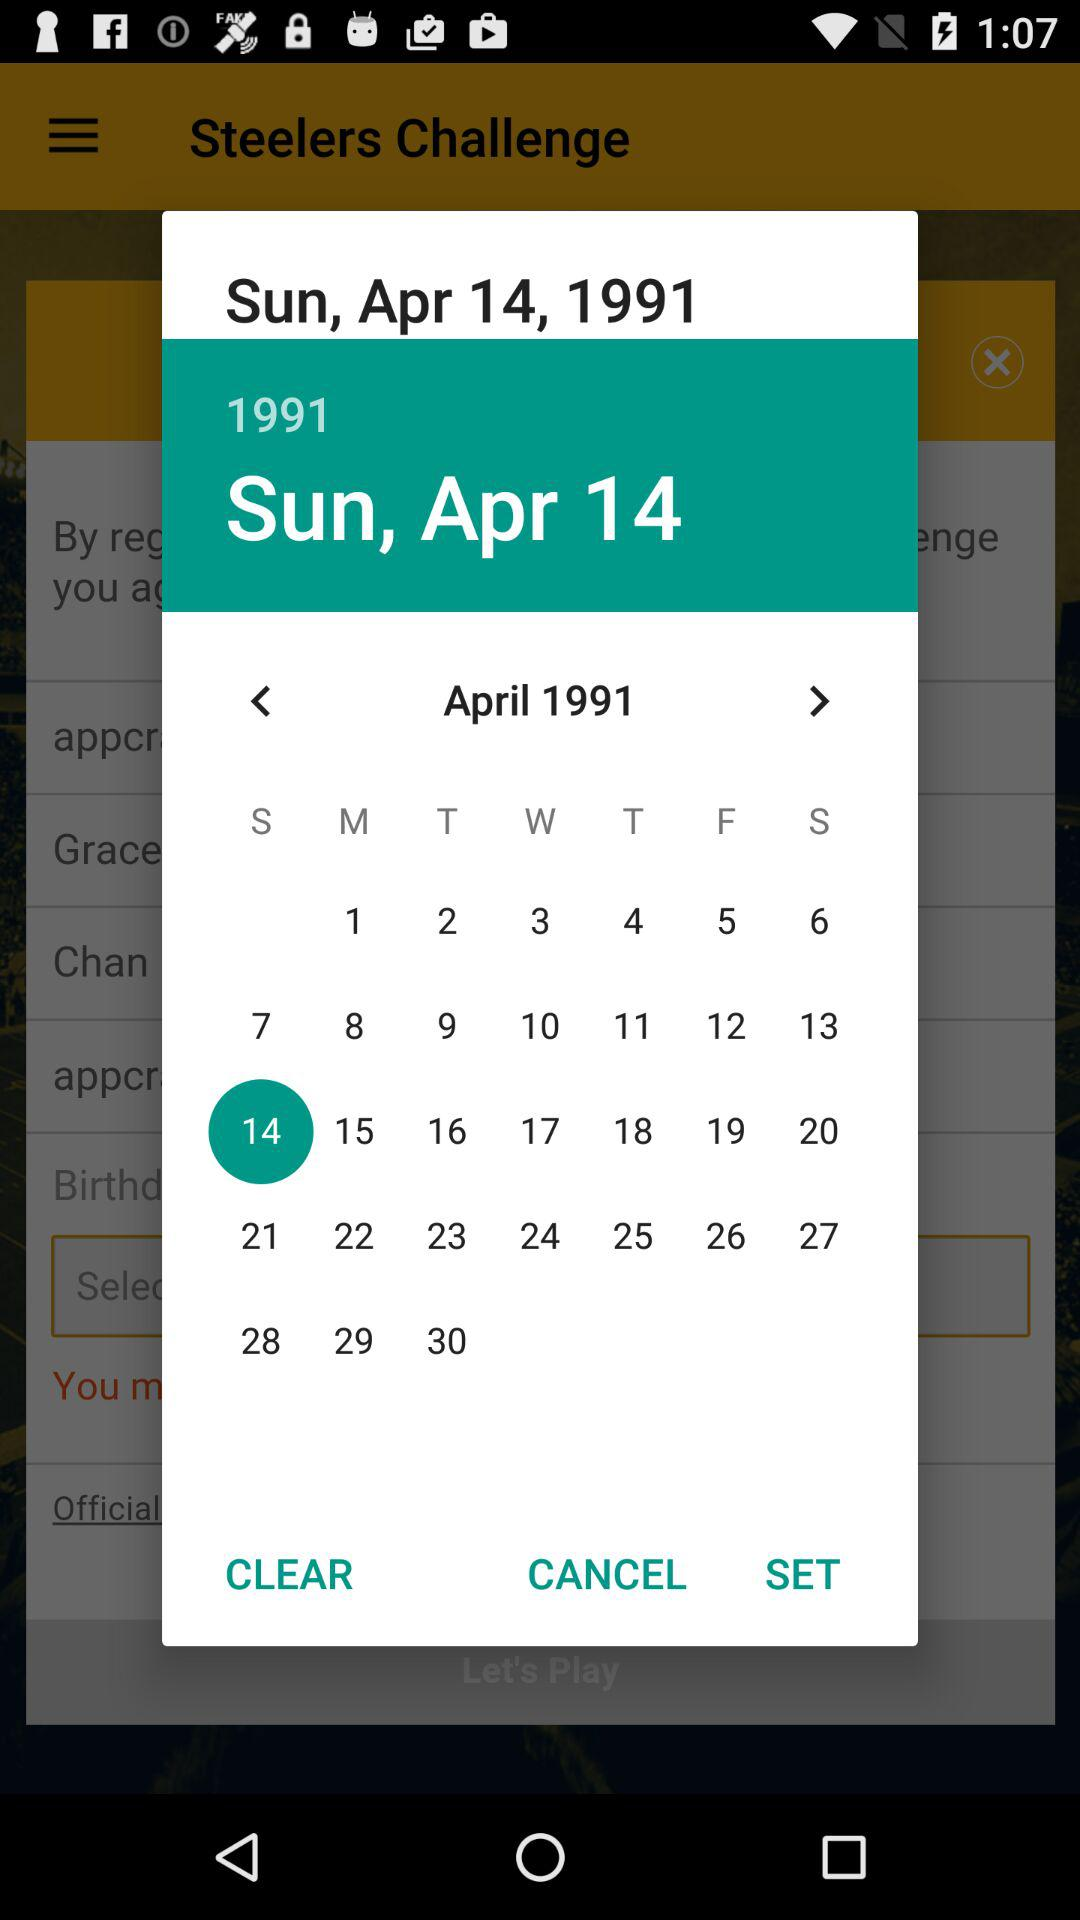What date is scheduled on the calendar? The date is Sunday, April 14, 1991. 